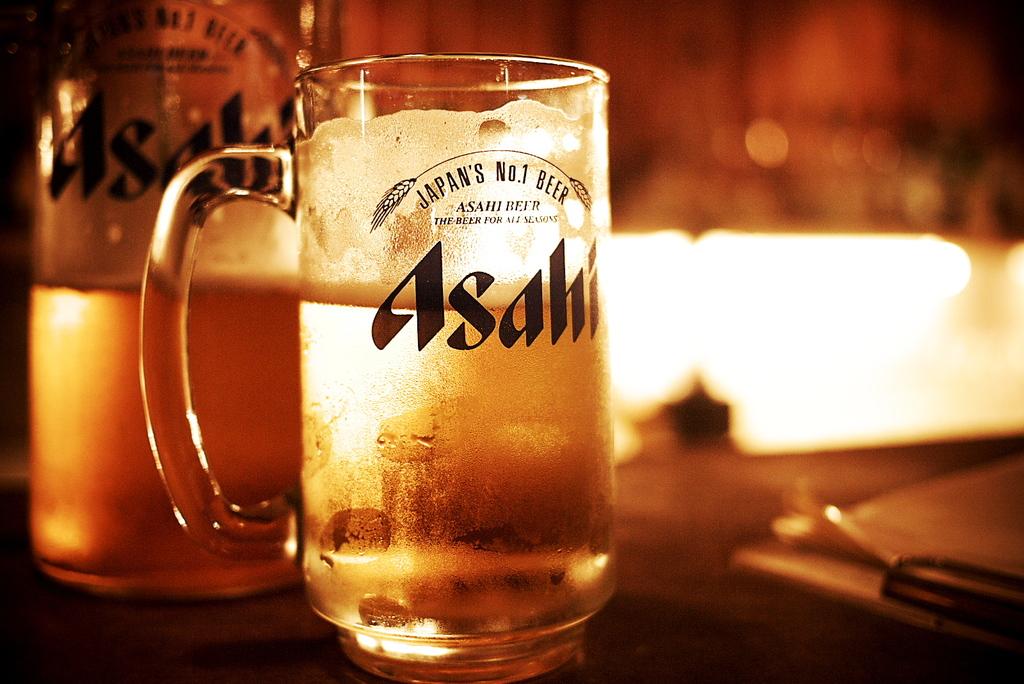What country is this beer brewed in?
Your answer should be compact. Japan. Which season is the beer for?
Provide a succinct answer. Unanswerable. 